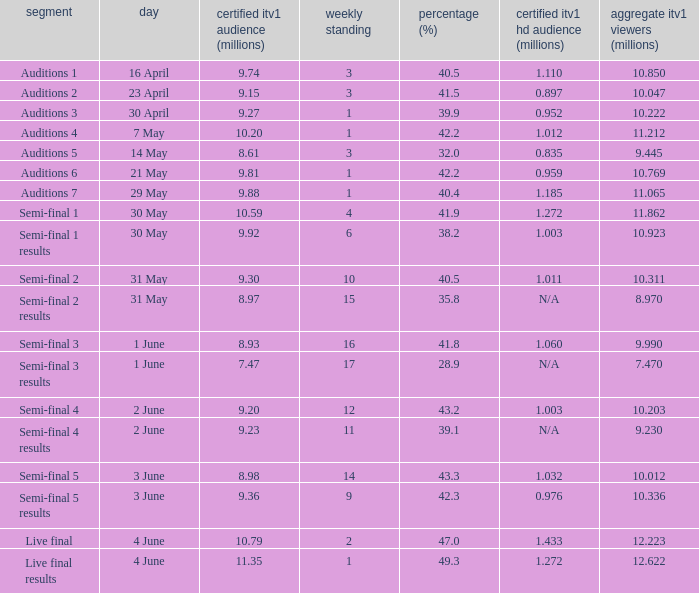What was the share (%) for the Semi-Final 2 episode?  40.5. 